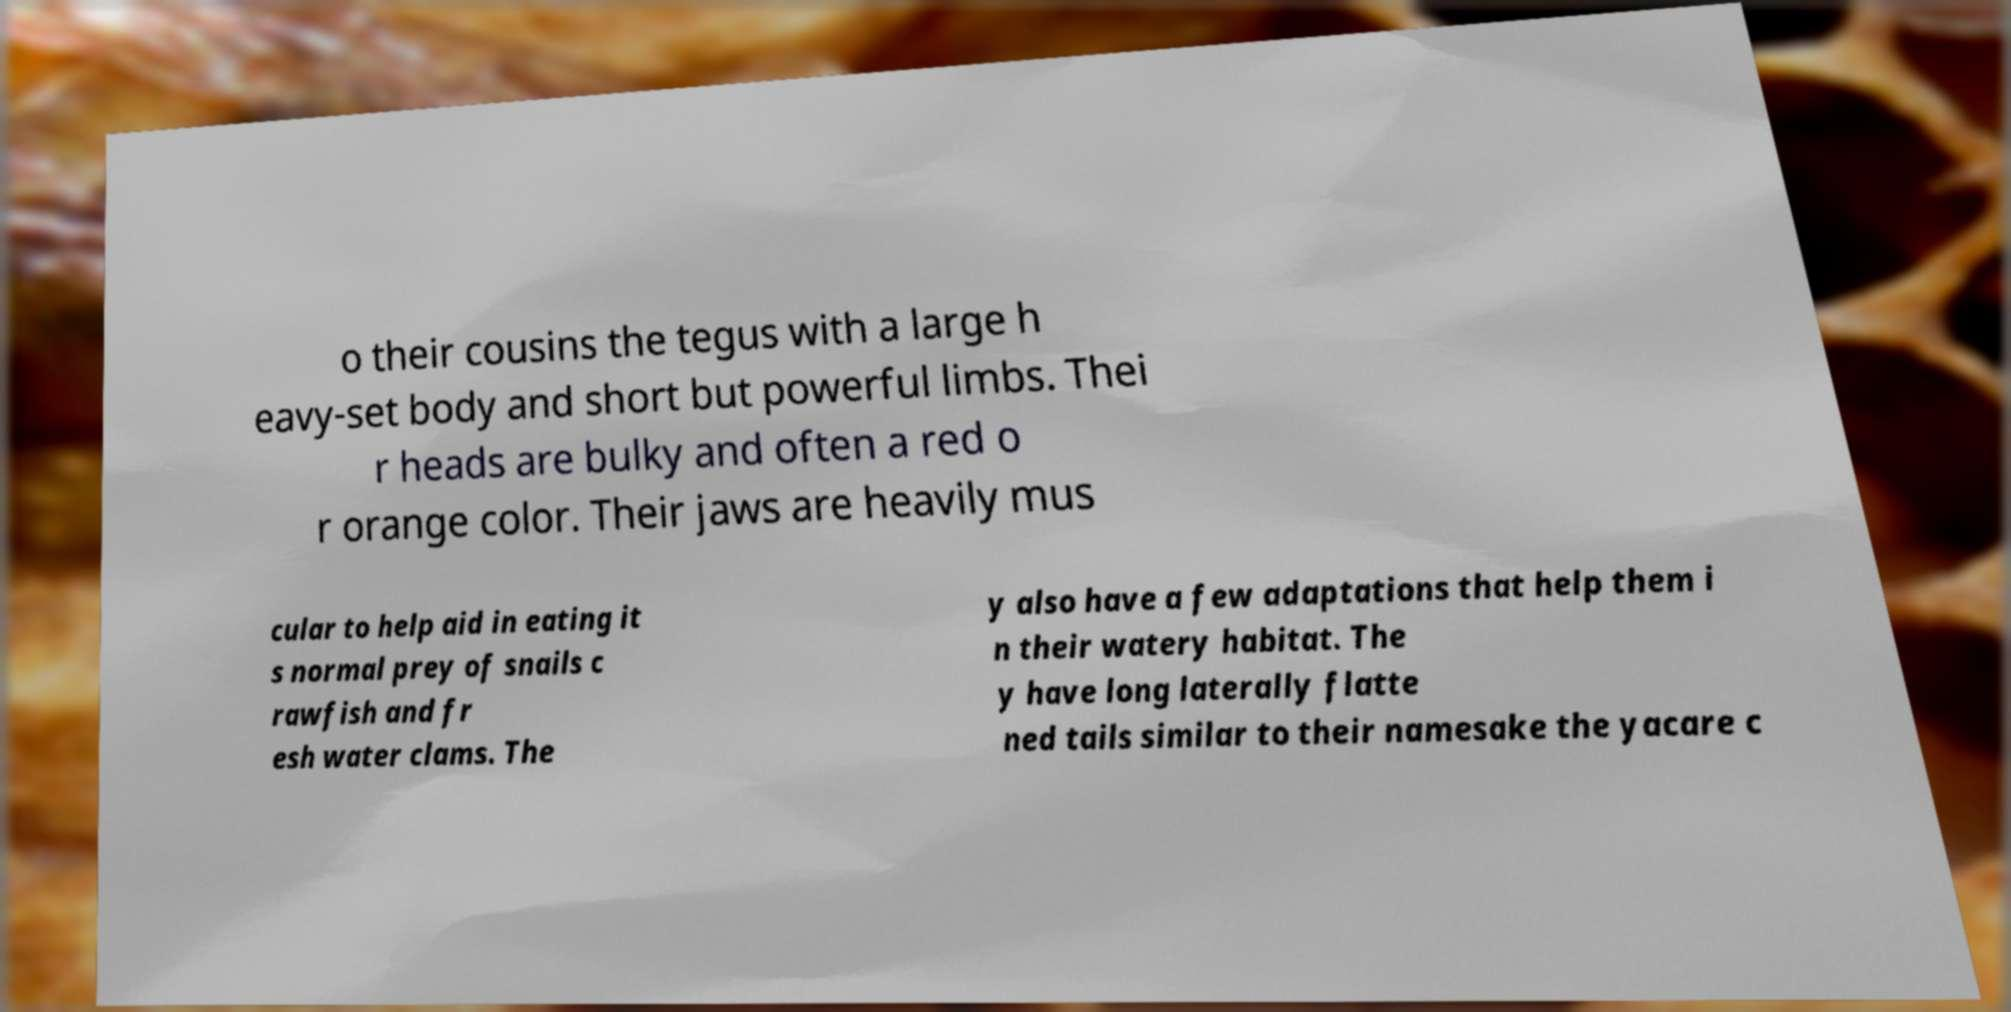What messages or text are displayed in this image? I need them in a readable, typed format. o their cousins the tegus with a large h eavy-set body and short but powerful limbs. Thei r heads are bulky and often a red o r orange color. Their jaws are heavily mus cular to help aid in eating it s normal prey of snails c rawfish and fr esh water clams. The y also have a few adaptations that help them i n their watery habitat. The y have long laterally flatte ned tails similar to their namesake the yacare c 